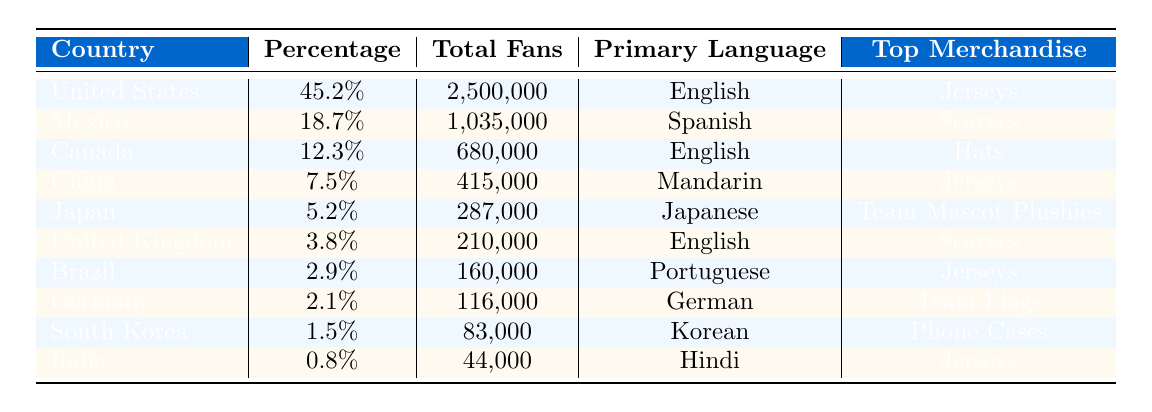What is the top merchandise sold in the United States? The table lists the top merchandise sold for each country, and for the United States, it states "Jerseys" as the top merchandise.
Answer: Jerseys Which country has the highest percentage of the fan base? By examining the percentages listed in the table for each country, the United States has the highest percentage at 45.2%.
Answer: United States How many total fans are there from Canada? The table provides the total number of fans from Canada as 680,000, which is directly stated.
Answer: 680,000 What is the primary language spoken by fans from China? The table shows that the primary language for fans from China is "Mandarin."
Answer: Mandarin What is the difference in total fans between Mexico and Brazil? The total fans from Mexico is 1,035,000 and from Brazil is 160,000. The difference is calculated as 1,035,000 - 160,000 = 875,000.
Answer: 875,000 Which country has the smallest fan base and what is its total? In the table, India has the smallest total fans with a number of 44,000, as this is the lowest figure listed.
Answer: 44,000 Is there a country where "Scarves" is the top merchandise sold? By looking at the table, we see that both Mexico and the United Kingdom have "Scarves" listed as their top merchandise sold, so the answer is yes.
Answer: Yes What percentage of the fan base comes from countries where English is the primary language? Adding the percentages for countries where English is the primary language: United States (45.2%) + Canada (12.3%) + United Kingdom (3.8%) gives us a total of 61.3%.
Answer: 61.3% Which country has the highest total number of fans selling "Jerseys"? The USA and China both sell "Jerseys," but the USA has a higher total fan count of 2,500,000 compared to China's 415,000. Therefore, the USA has the highest number.
Answer: United States How many fans are there from countries where the primary language is not English or Spanish? From the table, the countries with primary languages not English or Spanish are China, Japan, Germany, South Korea, and India. Their total fans add up: 415,000 + 287,000 + 116,000 + 83,000 + 44,000 = 945,000.
Answer: 945,000 